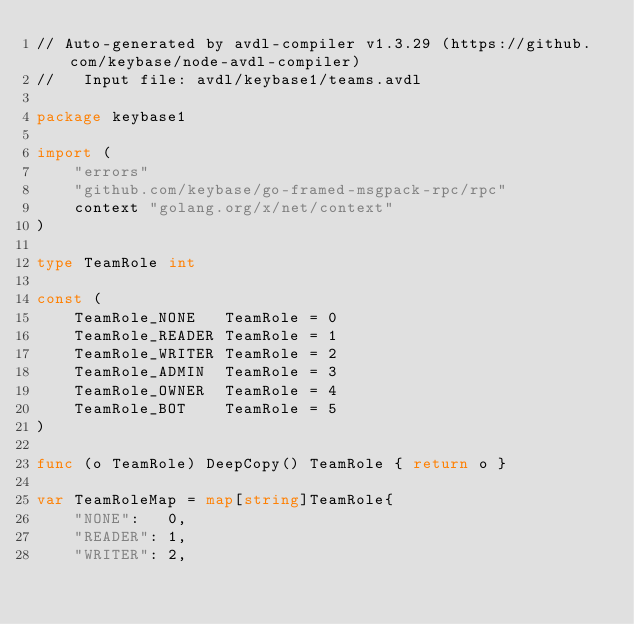Convert code to text. <code><loc_0><loc_0><loc_500><loc_500><_Go_>// Auto-generated by avdl-compiler v1.3.29 (https://github.com/keybase/node-avdl-compiler)
//   Input file: avdl/keybase1/teams.avdl

package keybase1

import (
	"errors"
	"github.com/keybase/go-framed-msgpack-rpc/rpc"
	context "golang.org/x/net/context"
)

type TeamRole int

const (
	TeamRole_NONE   TeamRole = 0
	TeamRole_READER TeamRole = 1
	TeamRole_WRITER TeamRole = 2
	TeamRole_ADMIN  TeamRole = 3
	TeamRole_OWNER  TeamRole = 4
	TeamRole_BOT    TeamRole = 5
)

func (o TeamRole) DeepCopy() TeamRole { return o }

var TeamRoleMap = map[string]TeamRole{
	"NONE":   0,
	"READER": 1,
	"WRITER": 2,</code> 